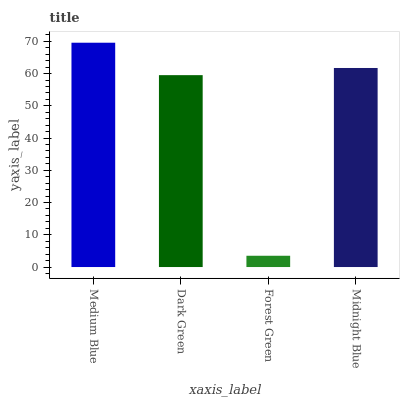Is Forest Green the minimum?
Answer yes or no. Yes. Is Medium Blue the maximum?
Answer yes or no. Yes. Is Dark Green the minimum?
Answer yes or no. No. Is Dark Green the maximum?
Answer yes or no. No. Is Medium Blue greater than Dark Green?
Answer yes or no. Yes. Is Dark Green less than Medium Blue?
Answer yes or no. Yes. Is Dark Green greater than Medium Blue?
Answer yes or no. No. Is Medium Blue less than Dark Green?
Answer yes or no. No. Is Midnight Blue the high median?
Answer yes or no. Yes. Is Dark Green the low median?
Answer yes or no. Yes. Is Medium Blue the high median?
Answer yes or no. No. Is Medium Blue the low median?
Answer yes or no. No. 